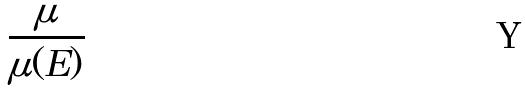<formula> <loc_0><loc_0><loc_500><loc_500>\frac { \mu } { \mu ( E ) }</formula> 